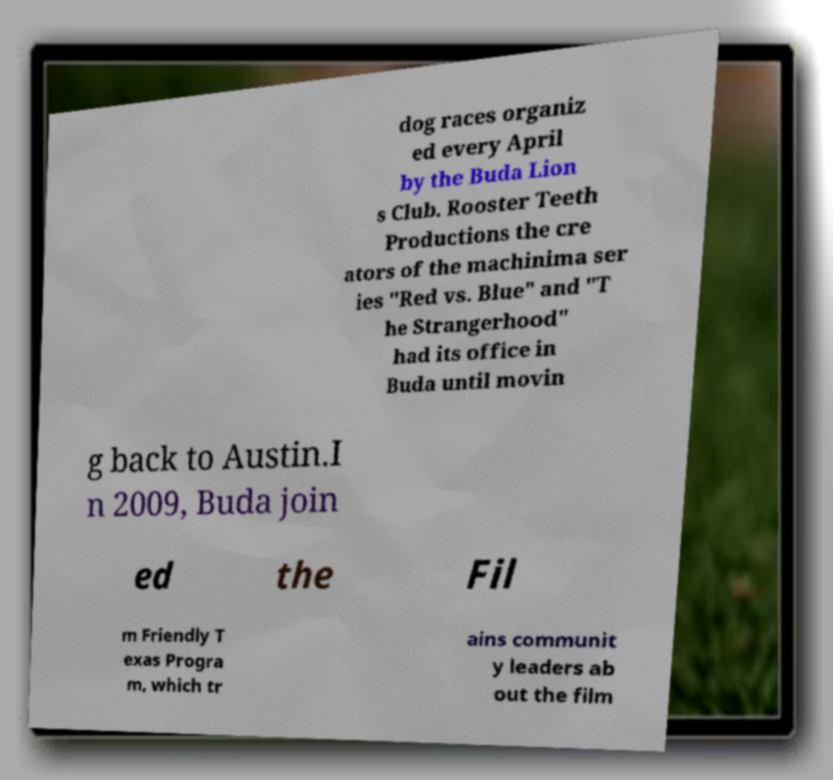There's text embedded in this image that I need extracted. Can you transcribe it verbatim? dog races organiz ed every April by the Buda Lion s Club. Rooster Teeth Productions the cre ators of the machinima ser ies "Red vs. Blue" and "T he Strangerhood" had its office in Buda until movin g back to Austin.I n 2009, Buda join ed the Fil m Friendly T exas Progra m, which tr ains communit y leaders ab out the film 